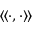Convert formula to latex. <formula><loc_0><loc_0><loc_500><loc_500>\langle \, \langle \cdot , \cdot \rangle \, \rangle</formula> 